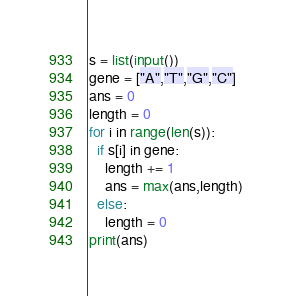<code> <loc_0><loc_0><loc_500><loc_500><_Python_>s = list(input())
gene = ["A","T","G","C"]
ans = 0
length = 0
for i in range(len(s)):
  if s[i] in gene:
    length += 1
    ans = max(ans,length)
  else:
    length = 0
print(ans)</code> 